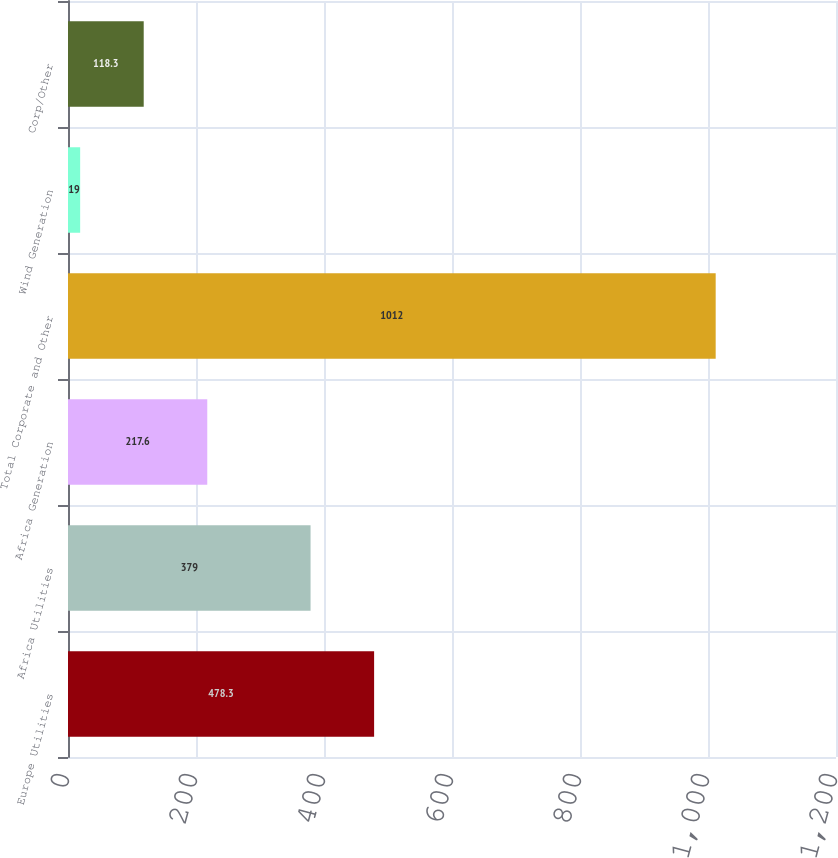Convert chart to OTSL. <chart><loc_0><loc_0><loc_500><loc_500><bar_chart><fcel>Europe Utilities<fcel>Africa Utilities<fcel>Africa Generation<fcel>Total Corporate and Other<fcel>Wind Generation<fcel>Corp/Other<nl><fcel>478.3<fcel>379<fcel>217.6<fcel>1012<fcel>19<fcel>118.3<nl></chart> 